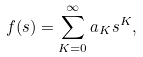Convert formula to latex. <formula><loc_0><loc_0><loc_500><loc_500>f ( s ) = \sum _ { K = 0 } ^ { \infty } a _ { K } s ^ { K } ,</formula> 